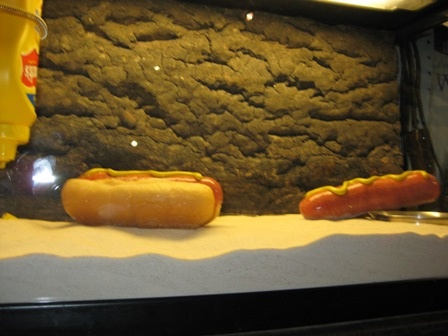Describe the objects in this image and their specific colors. I can see hot dog in olive, orange, maroon, and gold tones, bottle in olive, orange, and red tones, and hot dog in olive, maroon, brown, and orange tones in this image. 